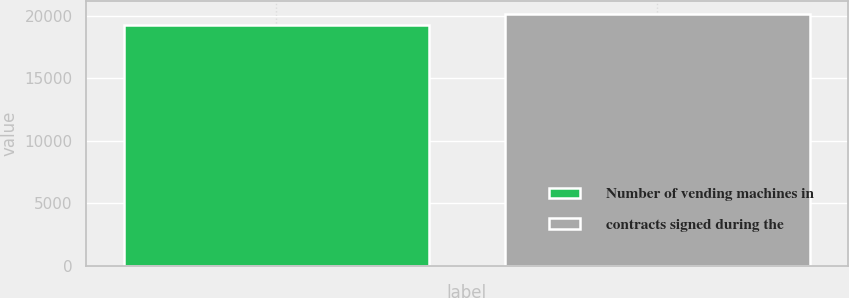<chart> <loc_0><loc_0><loc_500><loc_500><bar_chart><fcel>Number of vending machines in<fcel>contracts signed during the<nl><fcel>19305<fcel>20162<nl></chart> 